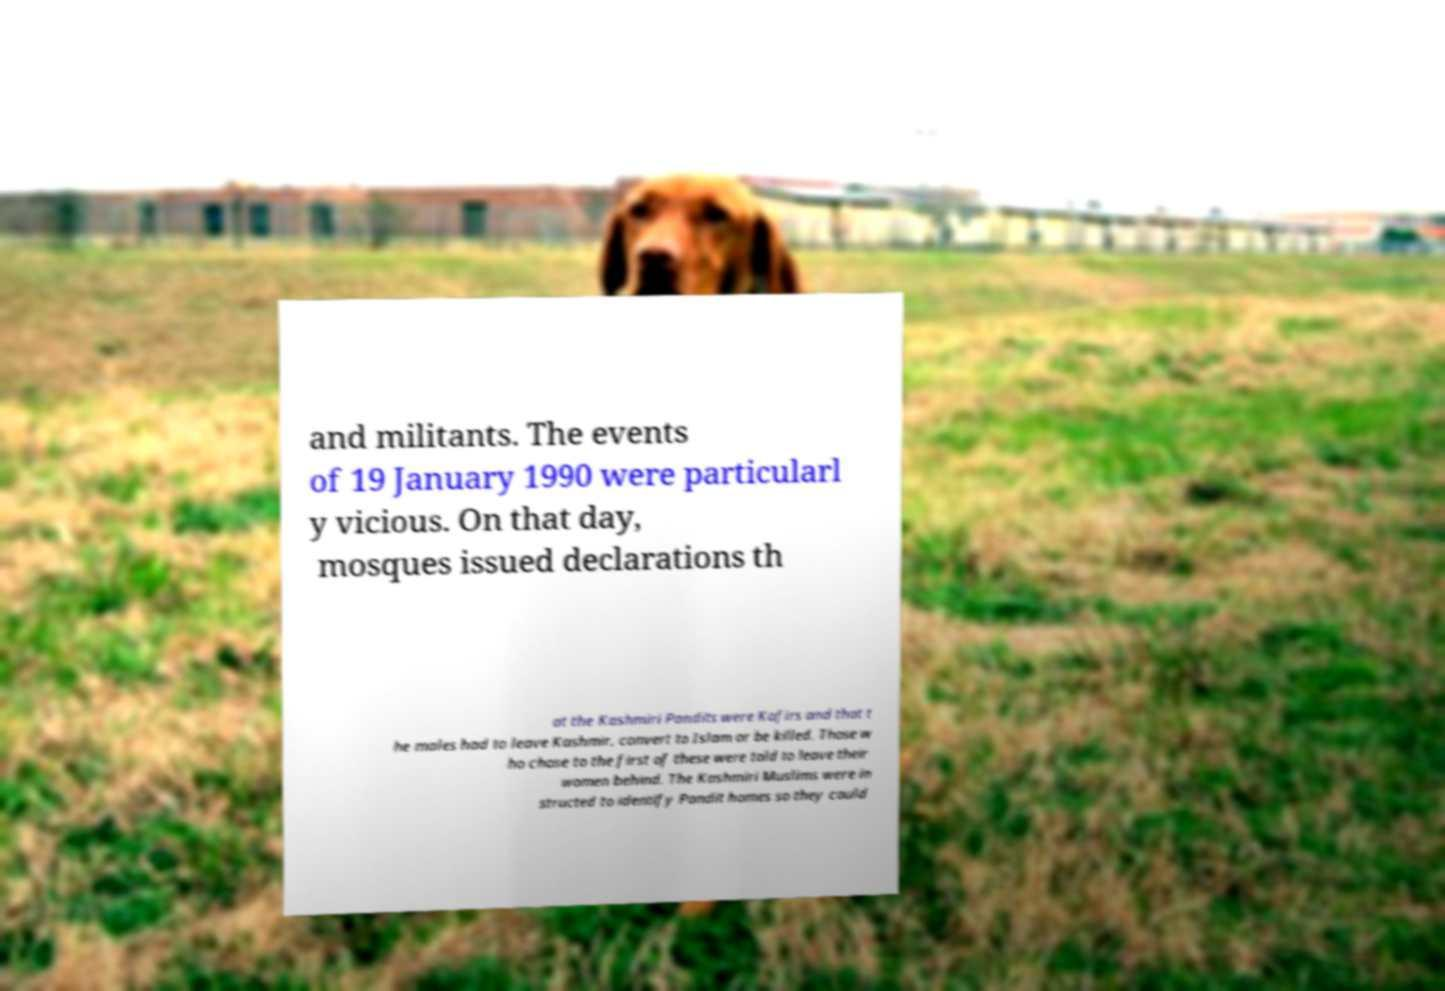There's text embedded in this image that I need extracted. Can you transcribe it verbatim? and militants. The events of 19 January 1990 were particularl y vicious. On that day, mosques issued declarations th at the Kashmiri Pandits were Kafirs and that t he males had to leave Kashmir, convert to Islam or be killed. Those w ho chose to the first of these were told to leave their women behind. The Kashmiri Muslims were in structed to identify Pandit homes so they could 